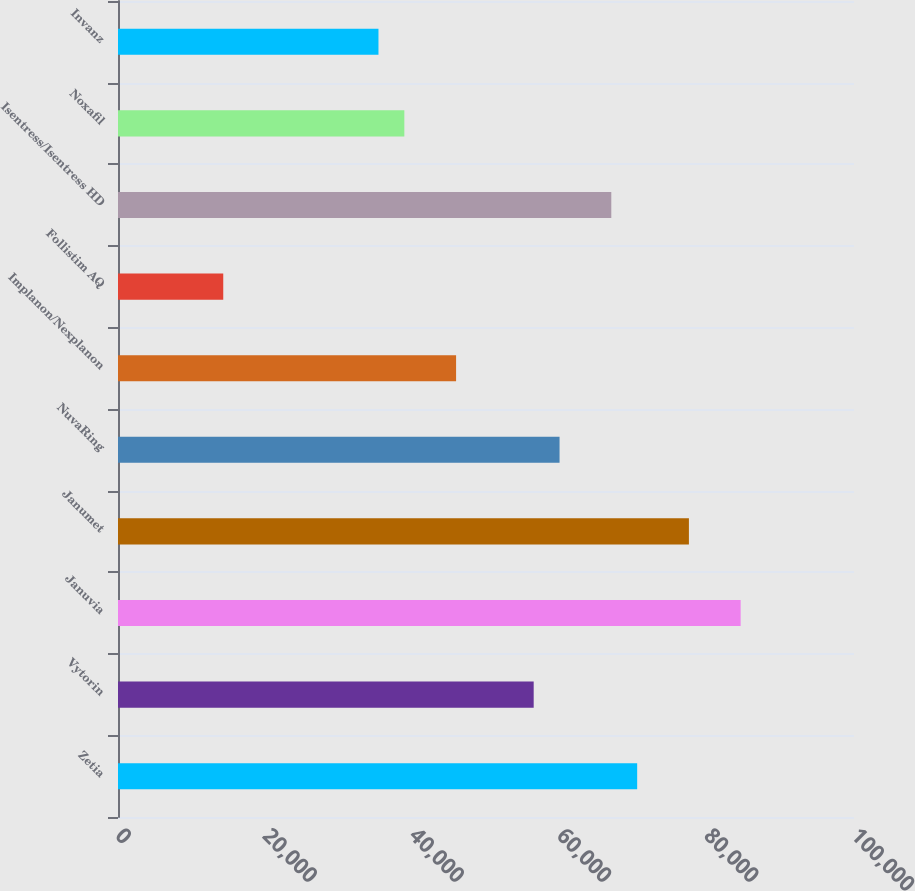Convert chart. <chart><loc_0><loc_0><loc_500><loc_500><bar_chart><fcel>Zetia<fcel>Vytorin<fcel>Januvia<fcel>Janumet<fcel>NuvaRing<fcel>Implanon/Nexplanon<fcel>Follistim AQ<fcel>Isentress/Isentress HD<fcel>Noxafil<fcel>Invanz<nl><fcel>70539<fcel>56479.4<fcel>84598.6<fcel>77568.8<fcel>59994.3<fcel>45934.7<fcel>14300.6<fcel>67024.1<fcel>38904.9<fcel>35390<nl></chart> 